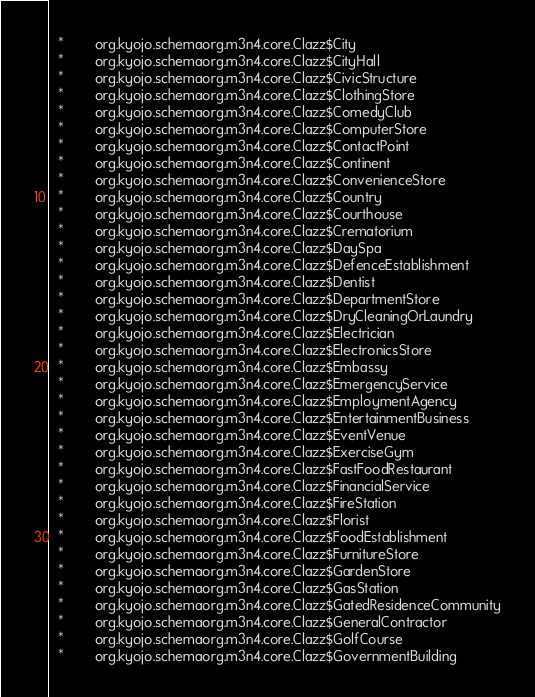Convert code to text. <code><loc_0><loc_0><loc_500><loc_500><_SQL_>  *        org.kyojo.schemaorg.m3n4.core.Clazz$City
  *        org.kyojo.schemaorg.m3n4.core.Clazz$CityHall
  *        org.kyojo.schemaorg.m3n4.core.Clazz$CivicStructure
  *        org.kyojo.schemaorg.m3n4.core.Clazz$ClothingStore
  *        org.kyojo.schemaorg.m3n4.core.Clazz$ComedyClub
  *        org.kyojo.schemaorg.m3n4.core.Clazz$ComputerStore
  *        org.kyojo.schemaorg.m3n4.core.Clazz$ContactPoint
  *        org.kyojo.schemaorg.m3n4.core.Clazz$Continent
  *        org.kyojo.schemaorg.m3n4.core.Clazz$ConvenienceStore
  *        org.kyojo.schemaorg.m3n4.core.Clazz$Country
  *        org.kyojo.schemaorg.m3n4.core.Clazz$Courthouse
  *        org.kyojo.schemaorg.m3n4.core.Clazz$Crematorium
  *        org.kyojo.schemaorg.m3n4.core.Clazz$DaySpa
  *        org.kyojo.schemaorg.m3n4.core.Clazz$DefenceEstablishment
  *        org.kyojo.schemaorg.m3n4.core.Clazz$Dentist
  *        org.kyojo.schemaorg.m3n4.core.Clazz$DepartmentStore
  *        org.kyojo.schemaorg.m3n4.core.Clazz$DryCleaningOrLaundry
  *        org.kyojo.schemaorg.m3n4.core.Clazz$Electrician
  *        org.kyojo.schemaorg.m3n4.core.Clazz$ElectronicsStore
  *        org.kyojo.schemaorg.m3n4.core.Clazz$Embassy
  *        org.kyojo.schemaorg.m3n4.core.Clazz$EmergencyService
  *        org.kyojo.schemaorg.m3n4.core.Clazz$EmploymentAgency
  *        org.kyojo.schemaorg.m3n4.core.Clazz$EntertainmentBusiness
  *        org.kyojo.schemaorg.m3n4.core.Clazz$EventVenue
  *        org.kyojo.schemaorg.m3n4.core.Clazz$ExerciseGym
  *        org.kyojo.schemaorg.m3n4.core.Clazz$FastFoodRestaurant
  *        org.kyojo.schemaorg.m3n4.core.Clazz$FinancialService
  *        org.kyojo.schemaorg.m3n4.core.Clazz$FireStation
  *        org.kyojo.schemaorg.m3n4.core.Clazz$Florist
  *        org.kyojo.schemaorg.m3n4.core.Clazz$FoodEstablishment
  *        org.kyojo.schemaorg.m3n4.core.Clazz$FurnitureStore
  *        org.kyojo.schemaorg.m3n4.core.Clazz$GardenStore
  *        org.kyojo.schemaorg.m3n4.core.Clazz$GasStation
  *        org.kyojo.schemaorg.m3n4.core.Clazz$GatedResidenceCommunity
  *        org.kyojo.schemaorg.m3n4.core.Clazz$GeneralContractor
  *        org.kyojo.schemaorg.m3n4.core.Clazz$GolfCourse
  *        org.kyojo.schemaorg.m3n4.core.Clazz$GovernmentBuilding</code> 